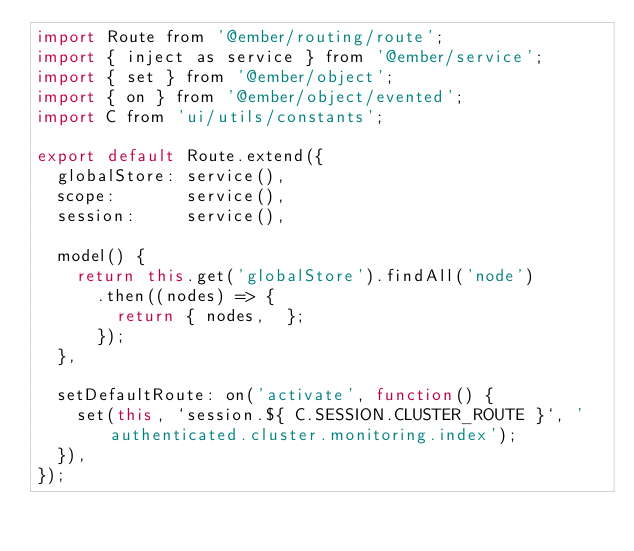Convert code to text. <code><loc_0><loc_0><loc_500><loc_500><_JavaScript_>import Route from '@ember/routing/route';
import { inject as service } from '@ember/service';
import { set } from '@ember/object';
import { on } from '@ember/object/evented';
import C from 'ui/utils/constants';

export default Route.extend({
  globalStore: service(),
  scope:       service(),
  session:     service(),

  model() {
    return this.get('globalStore').findAll('node')
      .then((nodes) => {
        return { nodes,  };
      });
  },

  setDefaultRoute: on('activate', function() {
    set(this, `session.${ C.SESSION.CLUSTER_ROUTE }`, 'authenticated.cluster.monitoring.index');
  }),
});
</code> 